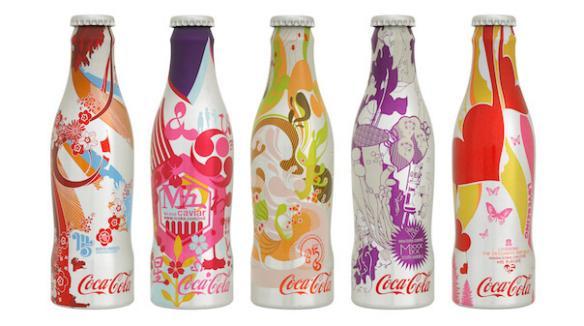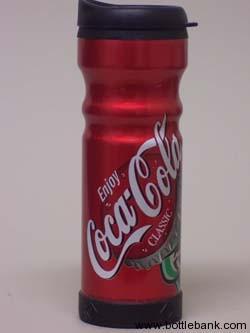The first image is the image on the left, the second image is the image on the right. Evaluate the accuracy of this statement regarding the images: "Some of the beverages are sugar free.". Is it true? Answer yes or no. No. 